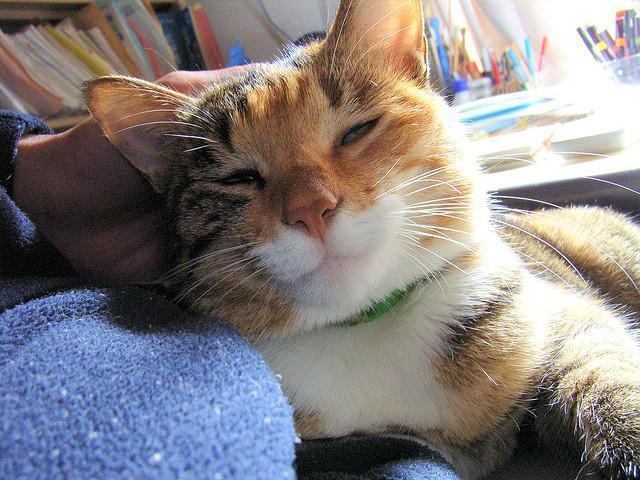How many books are there?
Give a very brief answer. 2. 